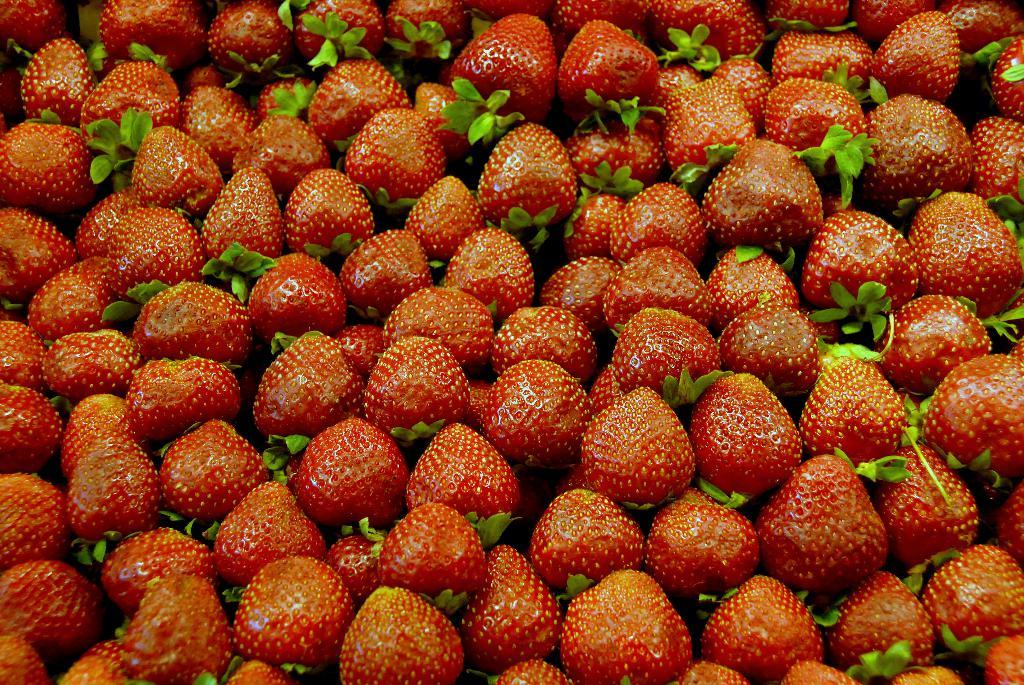What type of fruit is present in the image? There are strawberries in the image. What else can be seen in the image besides the strawberries? There are leaves in the image. What time is displayed on the clock in the image? There is no clock present in the image. How many visitors can be seen in the image? There are no visitors present in the image. 